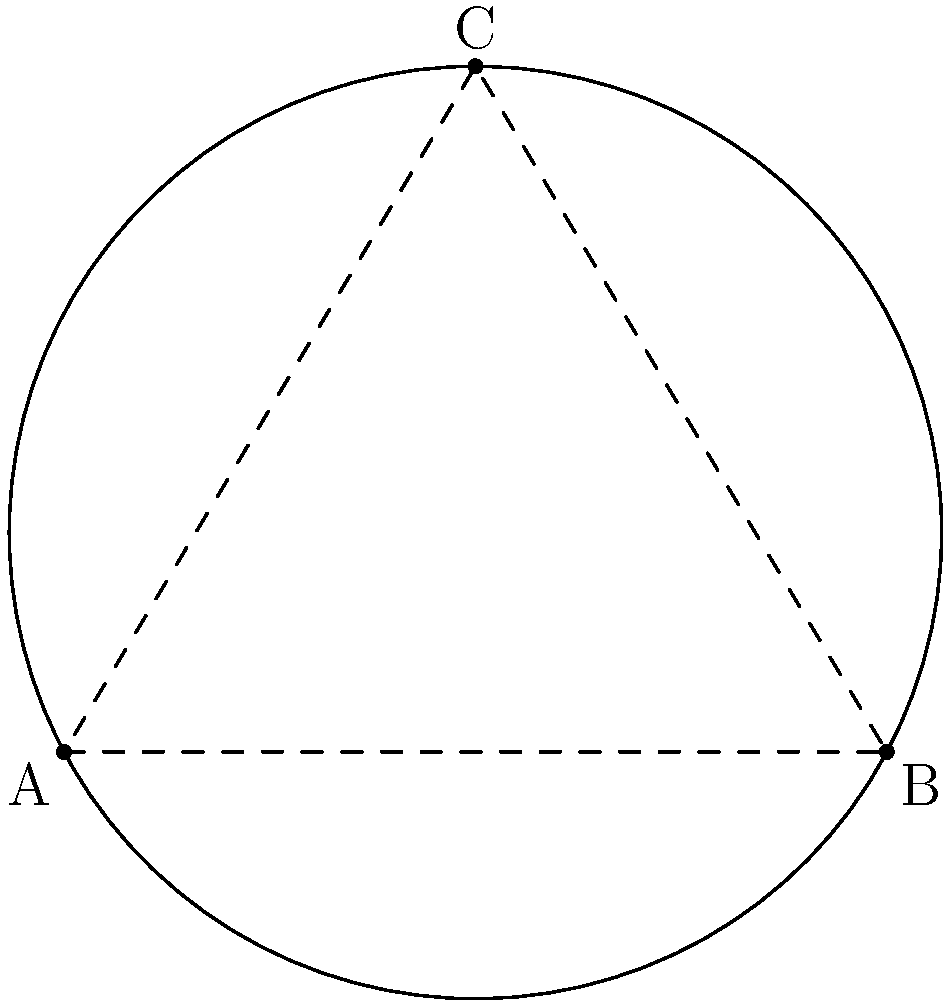As a senior .NET developer, you're working on a geometric calculation module. Given three points on a circle's circumference: A(0,0), B(6,0), and C(3,5), write a method to calculate the center coordinates and radius of the circle. What are the center coordinates (x, y) and radius r? To find the center and radius of a circle given three points, we can follow these steps:

1. First, we need to find the perpendicular bisectors of two chords. We'll use AB and BC.

2. For AB:
   Midpoint: $(\frac{0+6}{2}, \frac{0+0}{2}) = (3, 0)$
   Slope of AB: $m_{AB} = \frac{0-0}{6-0} = 0$
   Perpendicular slope: $m_{\perp AB} = -\frac{1}{m_{AB}} = \infty$ (vertical line)
   Equation of perpendicular bisector of AB: $x = 3$

3. For BC:
   Midpoint: $(\frac{6+3}{2}, \frac{0+5}{2}) = (4.5, 2.5)$
   Slope of BC: $m_{BC} = \frac{5-0}{3-6} = -\frac{5}{3}$
   Perpendicular slope: $m_{\perp BC} = \frac{3}{5}$
   Equation of perpendicular bisector of BC: $y - 2.5 = \frac{3}{5}(x - 4.5)$

4. The center is at the intersection of these two lines:
   $x = 3$
   $y - 2.5 = \frac{3}{5}(3 - 4.5) = -0.9$
   $y = 1.6$

   So, the center is at (3, 1.6)

5. To find the radius, we can calculate the distance from the center to any of the given points:

   $r = \sqrt{(3-0)^2 + (1.6-0)^2} = \sqrt{9 + 2.56} = \sqrt{11.56} \approx 3.4$

Therefore, the center coordinates are (3, 1.6) and the radius is approximately 3.4.
Answer: Center: (3, 1.6), Radius: 3.4 